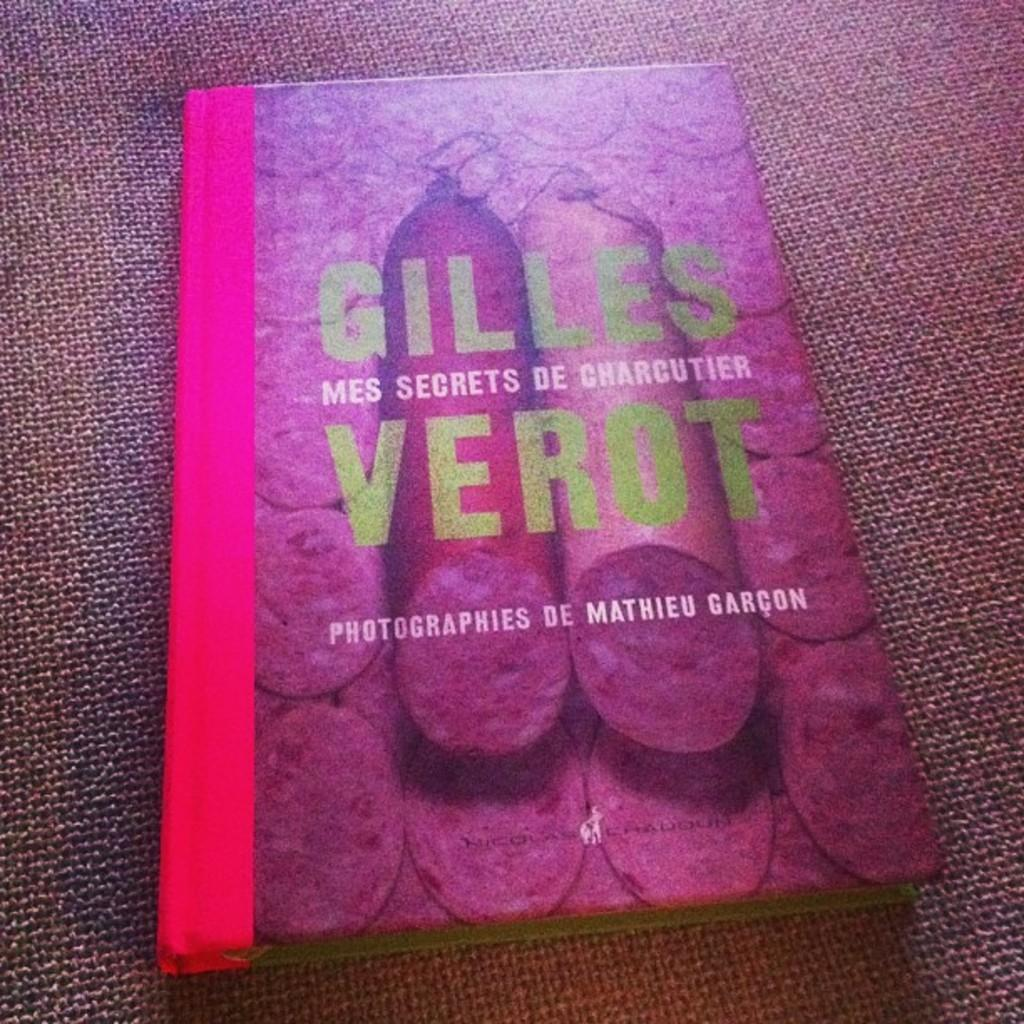<image>
Relay a brief, clear account of the picture shown. A photography book by Gilles Verot with tubes of meat on the cover. 